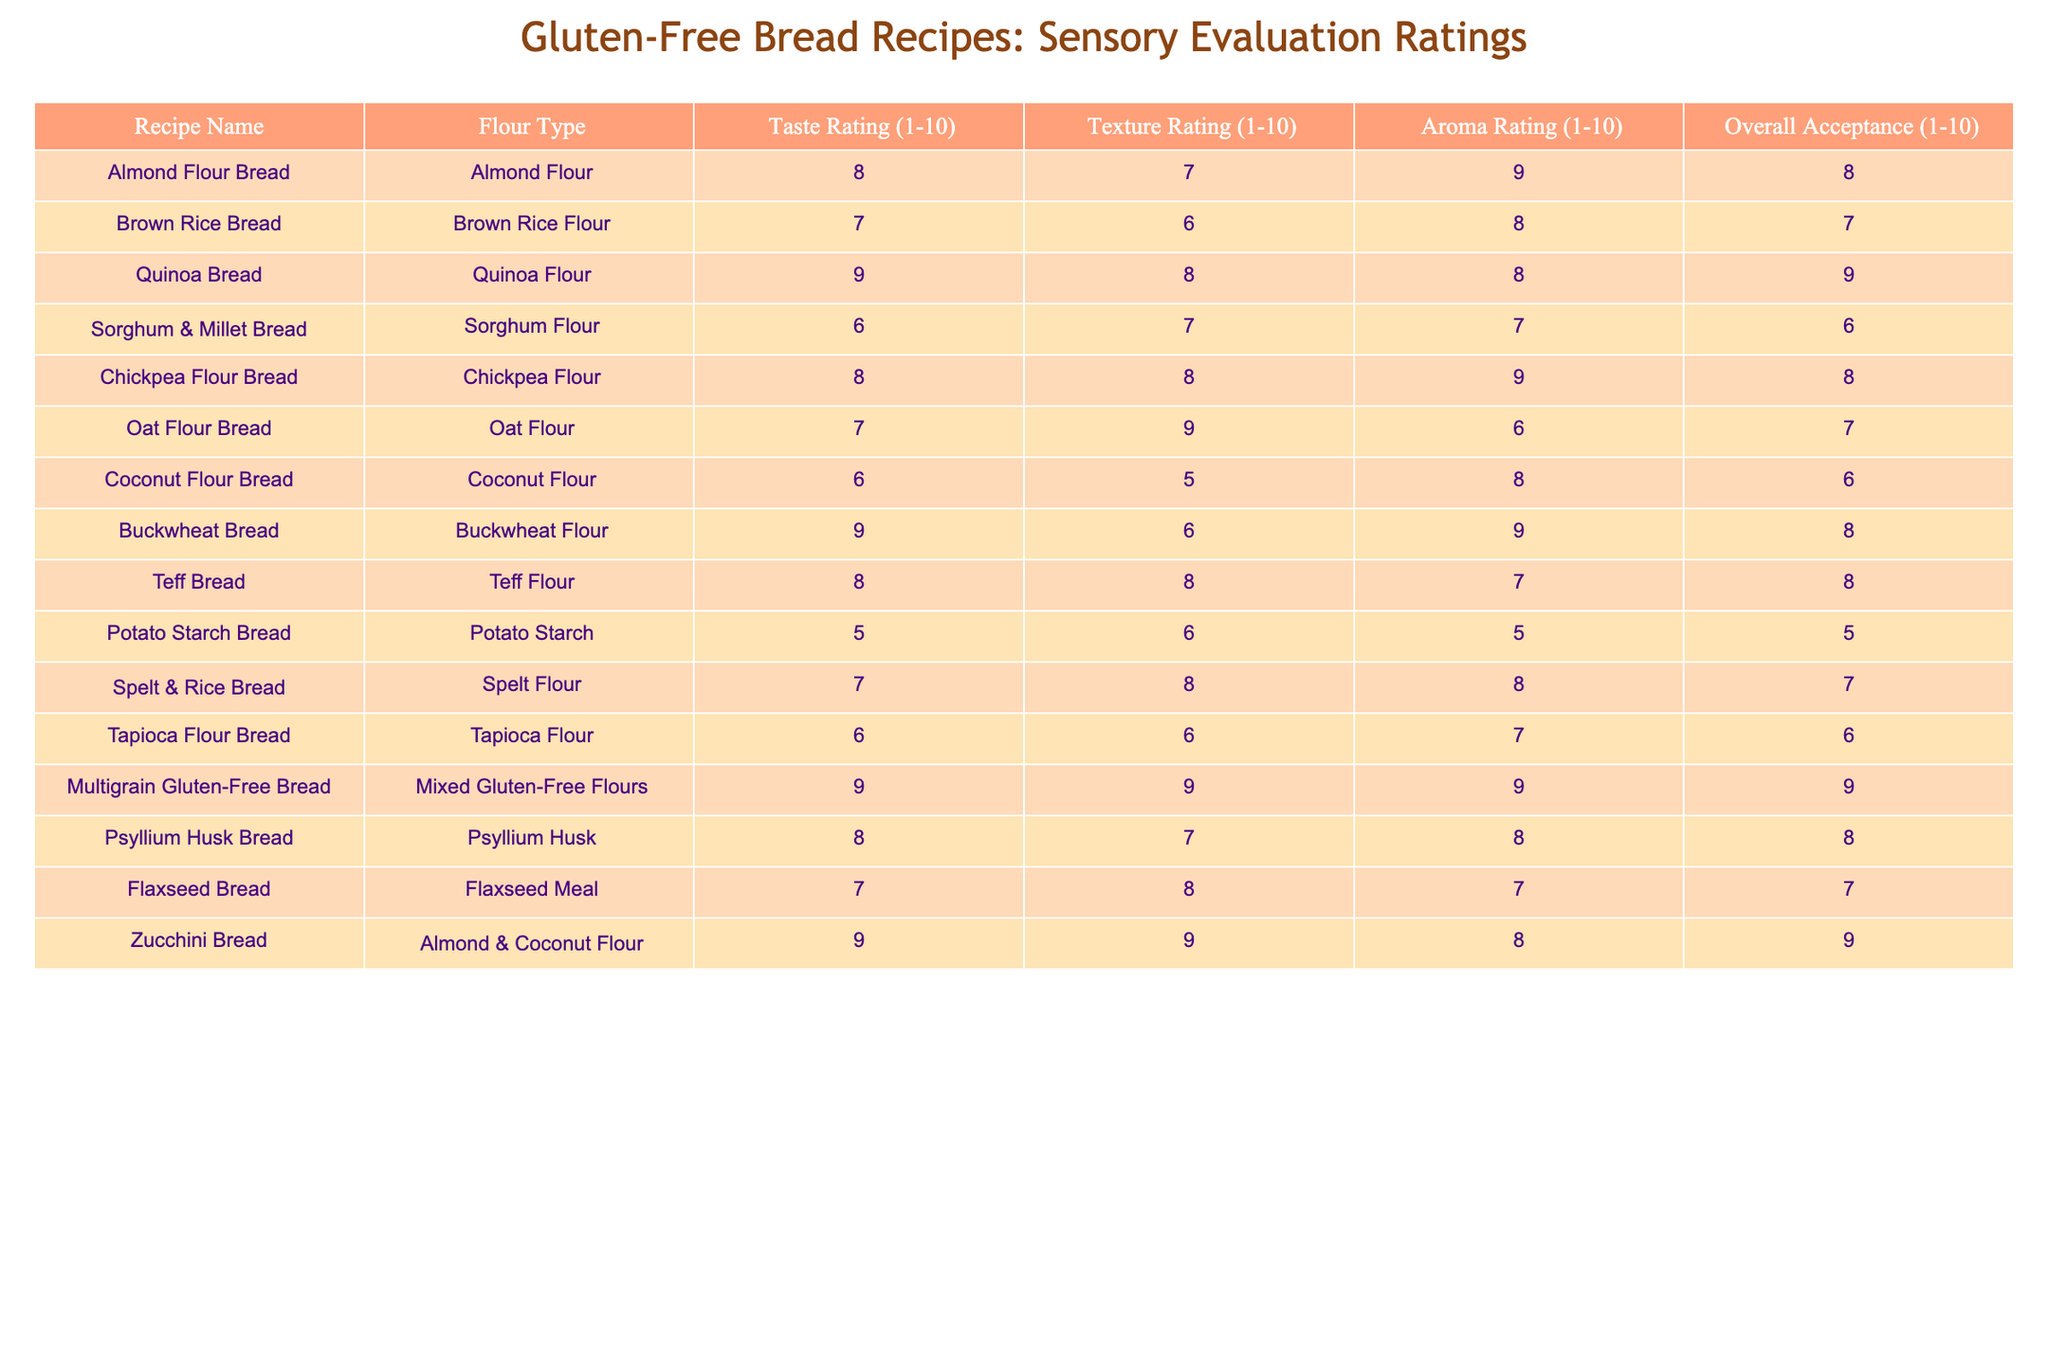What is the taste rating of the Quinoa Bread? The table shows that the taste rating for Quinoa Bread is listed as 9.
Answer: 9 Which bread has the highest overall acceptance rating? According to the table, Multigrain Gluten-Free Bread has the highest overall acceptance rating of 9.
Answer: 9 What is the average texture rating for the recipes using almond flour? The Almond Flour Bread has a texture rating of 7, and the Zucchini Bread (which uses almond flour) has a texture rating of 9. The average is (7 + 9) / 2 = 8.
Answer: 8 Is the aroma rating of the Chickpea Flour Bread higher than that of the Sourdough Bread (if it were included)? Since Sourdough Bread is not listed in the table, we can only compare the available data. The aroma rating for Chickpea Flour Bread is 9, which is a high rating likely to be higher than an average rating.
Answer: Yes/No (depending on availability) What is the texture rating difference between Buckwheat Bread and Coconut Flour Bread? The texture rating for Buckwheat Bread is 6, while Coconut Flour Bread has a rating of 5. The difference is 6 - 5 = 1.
Answer: 1 Which flour types have an overall acceptance rating of 8 or higher? By reviewing the overall acceptance ratings in the table, Quinoa Bread, Chickpea Flour Bread, Buckwheat Bread, Teff Bread, Multigrain Gluten-Free Bread, Psyllium Husk Bread, and Zucchini Bread all have ratings of 8 or higher.
Answer: Quinoa, Chickpea, Buckwheat, Teff, Multigrain, Psyllium Husk, Zucchini What is the median aroma rating among all the recipes? The aroma ratings are 9, 8, 8, 7, 7, 8, 9, 8, 9, 6, 6, 7, 5, and 8. When arranged in ascending order, the middle value (median) is 8.
Answer: 8 Does the Oat Flour Bread have a higher texture rating than the Potato Starch Bread? Oat Flour Bread has a texture rating of 9, while Potato Starch Bread has a rating of 6, which means Oat Flour Bread does have a higher texture rating.
Answer: Yes What percentage of the breads rated 8 or higher in overall acceptance? The total number of recipes is 14, and 7 breads have an overall acceptance rating of 8 or higher. Thus, the percentage is (7/14) * 100 = 50%.
Answer: 50% 